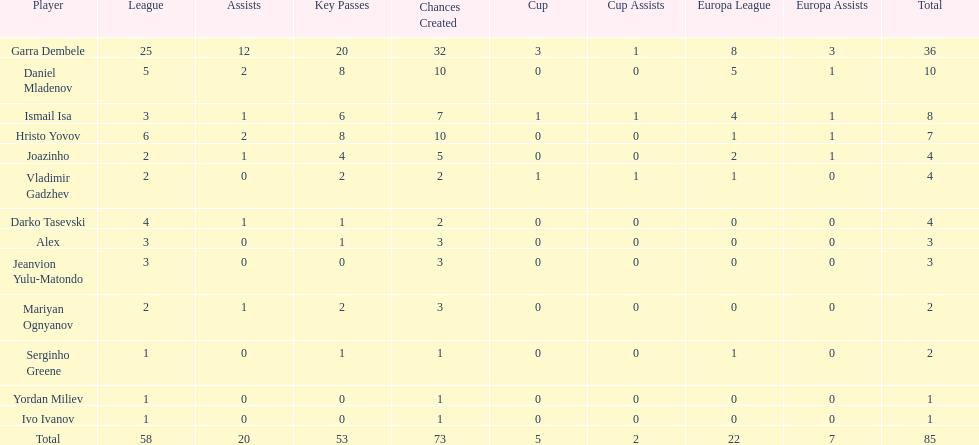Who are all of the players? Garra Dembele, Daniel Mladenov, Ismail Isa, Hristo Yovov, Joazinho, Vladimir Gadzhev, Darko Tasevski, Alex, Jeanvion Yulu-Matondo, Mariyan Ognyanov, Serginho Greene, Yordan Miliev, Ivo Ivanov. And which league is each player in? 25, 5, 3, 6, 2, 2, 4, 3, 3, 2, 1, 1, 1. Along with vladimir gadzhev and joazinho, which other player is in league 2? Mariyan Ognyanov. 